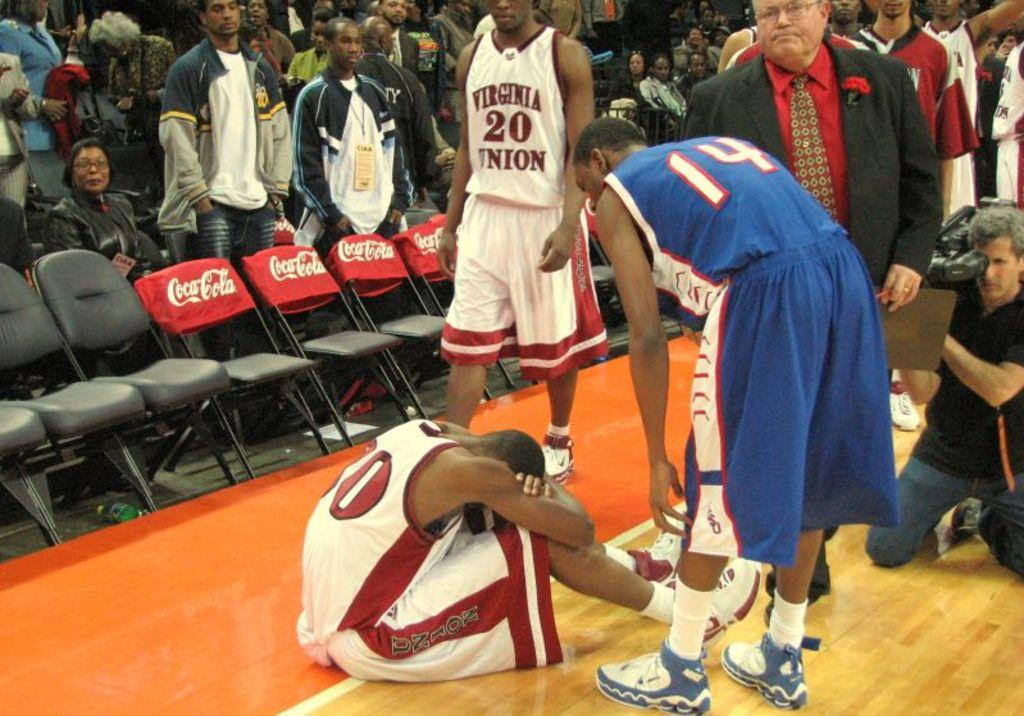<image>
Share a concise interpretation of the image provided. A few basket ball players standing on the side lines of the court with one jersey that says Virginia Union. 